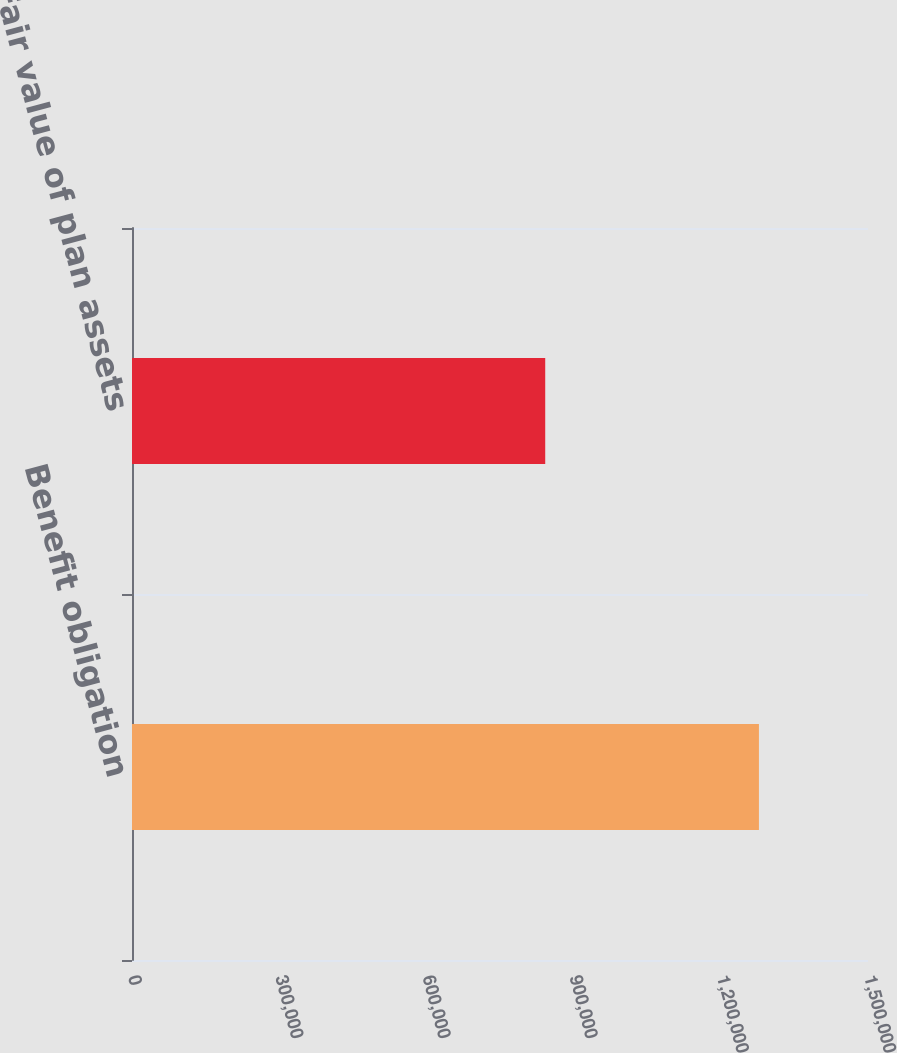<chart> <loc_0><loc_0><loc_500><loc_500><bar_chart><fcel>Benefit obligation<fcel>Fair value of plan assets<nl><fcel>1.27772e+06<fcel>842168<nl></chart> 